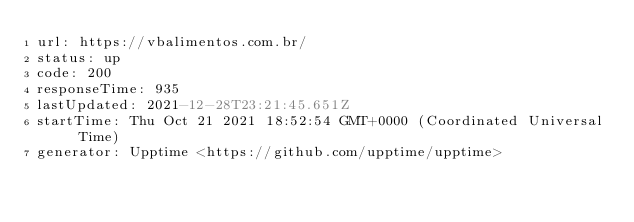<code> <loc_0><loc_0><loc_500><loc_500><_YAML_>url: https://vbalimentos.com.br/
status: up
code: 200
responseTime: 935
lastUpdated: 2021-12-28T23:21:45.651Z
startTime: Thu Oct 21 2021 18:52:54 GMT+0000 (Coordinated Universal Time)
generator: Upptime <https://github.com/upptime/upptime>
</code> 